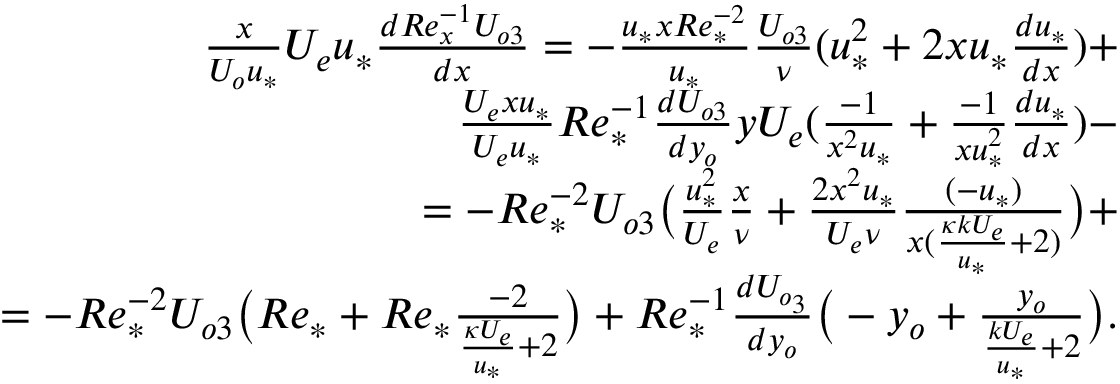Convert formula to latex. <formula><loc_0><loc_0><loc_500><loc_500>\begin{array} { r } { \frac { x } { U _ { o } u _ { * } } U _ { e } u _ { * } \frac { d R e _ { x } ^ { - 1 } U _ { o 3 } } { d x } = - \frac { u _ { * } x R e _ { * } ^ { - 2 } } { u _ { * } } \frac { U _ { o 3 } } { \nu } ( u _ { * } ^ { 2 } + 2 x u _ { * } \frac { d u _ { * } } { d x } ) + } \\ { \frac { U _ { e } x u _ { * } } { U _ { e } u _ { * } } R e _ { * } ^ { - 1 } \frac { d U _ { o 3 } } { d y _ { o } } y U _ { e } ( \frac { - 1 } { x ^ { 2 } u _ { * } } + \frac { - 1 } { x u _ { * } ^ { 2 } } \frac { d u _ { * } } { d x } ) - } \\ { = - R e _ { * } ^ { - 2 } U _ { o 3 } \left ( \frac { u _ { * } ^ { 2 } } { U _ { e } } \frac { x } { \nu } + \frac { 2 x ^ { 2 } u _ { * } } { U _ { e } \nu } \frac { ( - u _ { * } ) } { x ( \frac { \kappa k U _ { e } } { u _ { * } } + 2 ) } \right ) + } \\ { = - R e _ { * } ^ { - 2 } U _ { o 3 } \left ( R e _ { * } + R e _ { * } \frac { - 2 } { \frac { \kappa U _ { e } } { u _ { * } } + 2 } \right ) + R e _ { * } ^ { - 1 } \frac { d U _ { o _ { 3 } } } { d y _ { o } } \left ( - y _ { o } + \frac { y _ { o } } { \frac { k U _ { e } } { u _ { * } } + 2 } \right ) . } \end{array}</formula> 